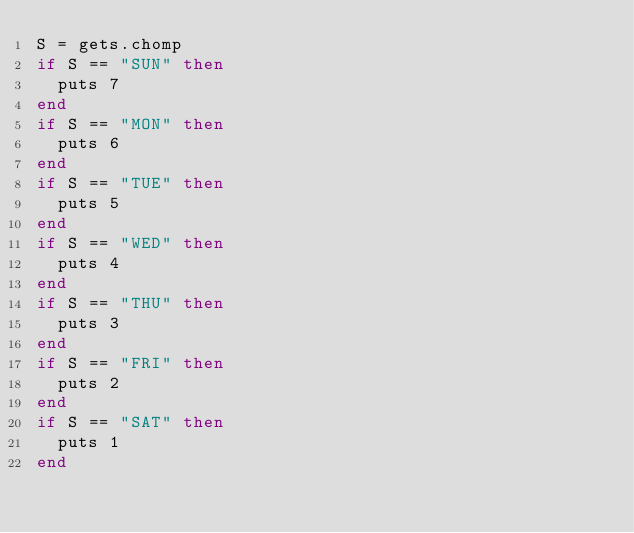Convert code to text. <code><loc_0><loc_0><loc_500><loc_500><_Ruby_>S = gets.chomp
if S == "SUN" then
  puts 7
end
if S == "MON" then
  puts 6
end
if S == "TUE" then
  puts 5
end
if S == "WED" then
  puts 4 
end
if S == "THU" then
  puts 3 
end
if S == "FRI" then
  puts 2
end
if S == "SAT" then
  puts 1
end</code> 